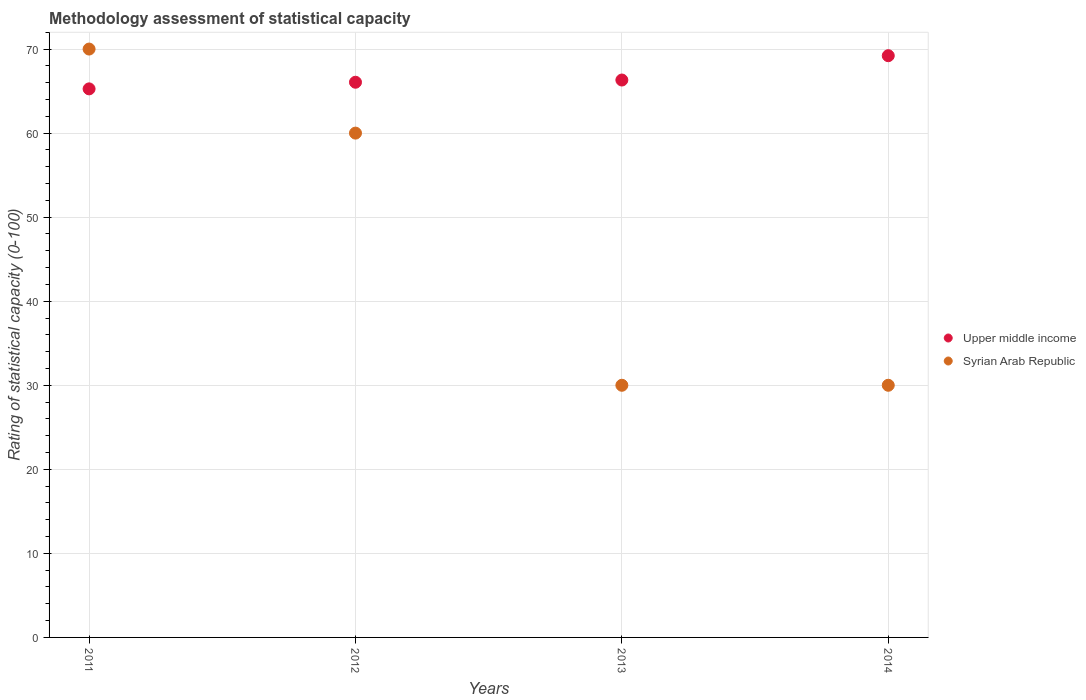How many different coloured dotlines are there?
Provide a succinct answer. 2. What is the rating of statistical capacity in Upper middle income in 2014?
Provide a succinct answer. 69.21. Across all years, what is the maximum rating of statistical capacity in Syrian Arab Republic?
Provide a short and direct response. 70. Across all years, what is the minimum rating of statistical capacity in Syrian Arab Republic?
Provide a short and direct response. 30. In which year was the rating of statistical capacity in Upper middle income maximum?
Keep it short and to the point. 2014. What is the total rating of statistical capacity in Upper middle income in the graph?
Provide a succinct answer. 266.84. What is the difference between the rating of statistical capacity in Syrian Arab Republic in 2012 and that in 2013?
Provide a short and direct response. 30. What is the difference between the rating of statistical capacity in Syrian Arab Republic in 2014 and the rating of statistical capacity in Upper middle income in 2012?
Provide a short and direct response. -36.05. What is the average rating of statistical capacity in Syrian Arab Republic per year?
Provide a succinct answer. 47.5. In the year 2013, what is the difference between the rating of statistical capacity in Upper middle income and rating of statistical capacity in Syrian Arab Republic?
Provide a succinct answer. 36.32. In how many years, is the rating of statistical capacity in Syrian Arab Republic greater than 18?
Your answer should be very brief. 4. What is the ratio of the rating of statistical capacity in Syrian Arab Republic in 2011 to that in 2012?
Your answer should be very brief. 1.17. Is the rating of statistical capacity in Upper middle income in 2012 less than that in 2013?
Offer a terse response. Yes. Is the difference between the rating of statistical capacity in Upper middle income in 2011 and 2014 greater than the difference between the rating of statistical capacity in Syrian Arab Republic in 2011 and 2014?
Keep it short and to the point. No. What is the difference between the highest and the lowest rating of statistical capacity in Upper middle income?
Keep it short and to the point. 3.95. Is the sum of the rating of statistical capacity in Upper middle income in 2013 and 2014 greater than the maximum rating of statistical capacity in Syrian Arab Republic across all years?
Give a very brief answer. Yes. Is the rating of statistical capacity in Upper middle income strictly greater than the rating of statistical capacity in Syrian Arab Republic over the years?
Provide a short and direct response. No. Is the rating of statistical capacity in Syrian Arab Republic strictly less than the rating of statistical capacity in Upper middle income over the years?
Offer a very short reply. No. How many years are there in the graph?
Your response must be concise. 4. How many legend labels are there?
Your answer should be very brief. 2. What is the title of the graph?
Keep it short and to the point. Methodology assessment of statistical capacity. Does "European Union" appear as one of the legend labels in the graph?
Offer a very short reply. No. What is the label or title of the Y-axis?
Provide a succinct answer. Rating of statistical capacity (0-100). What is the Rating of statistical capacity (0-100) of Upper middle income in 2011?
Provide a short and direct response. 65.26. What is the Rating of statistical capacity (0-100) in Syrian Arab Republic in 2011?
Offer a very short reply. 70. What is the Rating of statistical capacity (0-100) in Upper middle income in 2012?
Your answer should be very brief. 66.05. What is the Rating of statistical capacity (0-100) of Syrian Arab Republic in 2012?
Offer a very short reply. 60. What is the Rating of statistical capacity (0-100) in Upper middle income in 2013?
Give a very brief answer. 66.32. What is the Rating of statistical capacity (0-100) in Syrian Arab Republic in 2013?
Provide a succinct answer. 30. What is the Rating of statistical capacity (0-100) in Upper middle income in 2014?
Ensure brevity in your answer.  69.21. What is the Rating of statistical capacity (0-100) of Syrian Arab Republic in 2014?
Your answer should be compact. 30. Across all years, what is the maximum Rating of statistical capacity (0-100) in Upper middle income?
Your response must be concise. 69.21. Across all years, what is the maximum Rating of statistical capacity (0-100) of Syrian Arab Republic?
Provide a succinct answer. 70. Across all years, what is the minimum Rating of statistical capacity (0-100) in Upper middle income?
Provide a succinct answer. 65.26. Across all years, what is the minimum Rating of statistical capacity (0-100) of Syrian Arab Republic?
Make the answer very short. 30. What is the total Rating of statistical capacity (0-100) of Upper middle income in the graph?
Offer a very short reply. 266.84. What is the total Rating of statistical capacity (0-100) in Syrian Arab Republic in the graph?
Keep it short and to the point. 190. What is the difference between the Rating of statistical capacity (0-100) of Upper middle income in 2011 and that in 2012?
Keep it short and to the point. -0.79. What is the difference between the Rating of statistical capacity (0-100) of Syrian Arab Republic in 2011 and that in 2012?
Give a very brief answer. 10. What is the difference between the Rating of statistical capacity (0-100) of Upper middle income in 2011 and that in 2013?
Ensure brevity in your answer.  -1.05. What is the difference between the Rating of statistical capacity (0-100) of Upper middle income in 2011 and that in 2014?
Give a very brief answer. -3.95. What is the difference between the Rating of statistical capacity (0-100) of Upper middle income in 2012 and that in 2013?
Your answer should be very brief. -0.26. What is the difference between the Rating of statistical capacity (0-100) in Upper middle income in 2012 and that in 2014?
Your response must be concise. -3.16. What is the difference between the Rating of statistical capacity (0-100) of Syrian Arab Republic in 2012 and that in 2014?
Give a very brief answer. 30. What is the difference between the Rating of statistical capacity (0-100) of Upper middle income in 2013 and that in 2014?
Provide a short and direct response. -2.89. What is the difference between the Rating of statistical capacity (0-100) of Syrian Arab Republic in 2013 and that in 2014?
Give a very brief answer. 0. What is the difference between the Rating of statistical capacity (0-100) in Upper middle income in 2011 and the Rating of statistical capacity (0-100) in Syrian Arab Republic in 2012?
Make the answer very short. 5.26. What is the difference between the Rating of statistical capacity (0-100) in Upper middle income in 2011 and the Rating of statistical capacity (0-100) in Syrian Arab Republic in 2013?
Ensure brevity in your answer.  35.26. What is the difference between the Rating of statistical capacity (0-100) of Upper middle income in 2011 and the Rating of statistical capacity (0-100) of Syrian Arab Republic in 2014?
Your response must be concise. 35.26. What is the difference between the Rating of statistical capacity (0-100) in Upper middle income in 2012 and the Rating of statistical capacity (0-100) in Syrian Arab Republic in 2013?
Offer a terse response. 36.05. What is the difference between the Rating of statistical capacity (0-100) in Upper middle income in 2012 and the Rating of statistical capacity (0-100) in Syrian Arab Republic in 2014?
Your answer should be very brief. 36.05. What is the difference between the Rating of statistical capacity (0-100) of Upper middle income in 2013 and the Rating of statistical capacity (0-100) of Syrian Arab Republic in 2014?
Your response must be concise. 36.32. What is the average Rating of statistical capacity (0-100) in Upper middle income per year?
Give a very brief answer. 66.71. What is the average Rating of statistical capacity (0-100) of Syrian Arab Republic per year?
Your answer should be compact. 47.5. In the year 2011, what is the difference between the Rating of statistical capacity (0-100) of Upper middle income and Rating of statistical capacity (0-100) of Syrian Arab Republic?
Keep it short and to the point. -4.74. In the year 2012, what is the difference between the Rating of statistical capacity (0-100) of Upper middle income and Rating of statistical capacity (0-100) of Syrian Arab Republic?
Your answer should be compact. 6.05. In the year 2013, what is the difference between the Rating of statistical capacity (0-100) of Upper middle income and Rating of statistical capacity (0-100) of Syrian Arab Republic?
Provide a short and direct response. 36.32. In the year 2014, what is the difference between the Rating of statistical capacity (0-100) of Upper middle income and Rating of statistical capacity (0-100) of Syrian Arab Republic?
Provide a succinct answer. 39.21. What is the ratio of the Rating of statistical capacity (0-100) in Upper middle income in 2011 to that in 2012?
Keep it short and to the point. 0.99. What is the ratio of the Rating of statistical capacity (0-100) in Upper middle income in 2011 to that in 2013?
Give a very brief answer. 0.98. What is the ratio of the Rating of statistical capacity (0-100) in Syrian Arab Republic in 2011 to that in 2013?
Provide a succinct answer. 2.33. What is the ratio of the Rating of statistical capacity (0-100) of Upper middle income in 2011 to that in 2014?
Make the answer very short. 0.94. What is the ratio of the Rating of statistical capacity (0-100) of Syrian Arab Republic in 2011 to that in 2014?
Your answer should be very brief. 2.33. What is the ratio of the Rating of statistical capacity (0-100) in Upper middle income in 2012 to that in 2013?
Provide a short and direct response. 1. What is the ratio of the Rating of statistical capacity (0-100) of Upper middle income in 2012 to that in 2014?
Keep it short and to the point. 0.95. What is the ratio of the Rating of statistical capacity (0-100) in Syrian Arab Republic in 2012 to that in 2014?
Ensure brevity in your answer.  2. What is the ratio of the Rating of statistical capacity (0-100) in Upper middle income in 2013 to that in 2014?
Your response must be concise. 0.96. What is the difference between the highest and the second highest Rating of statistical capacity (0-100) in Upper middle income?
Provide a short and direct response. 2.89. What is the difference between the highest and the second highest Rating of statistical capacity (0-100) in Syrian Arab Republic?
Provide a short and direct response. 10. What is the difference between the highest and the lowest Rating of statistical capacity (0-100) of Upper middle income?
Your answer should be very brief. 3.95. 